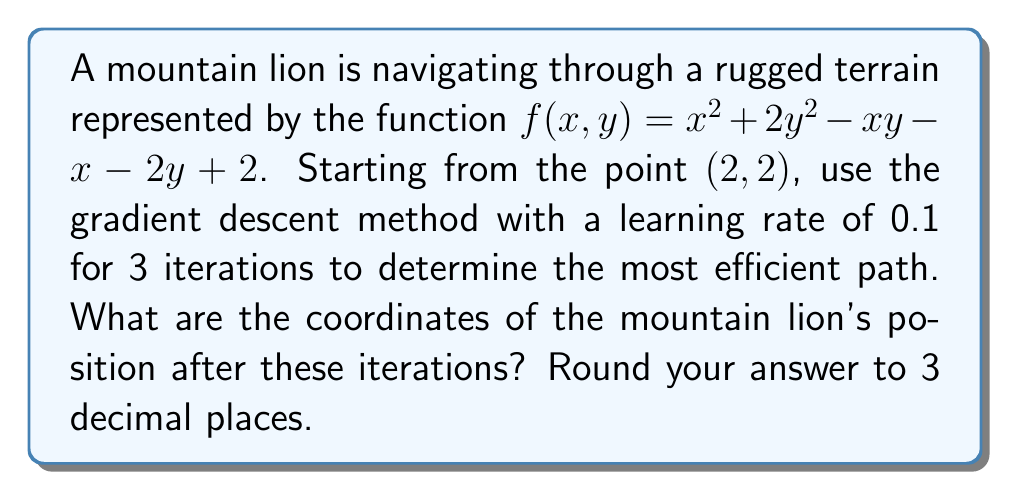Can you solve this math problem? To solve this problem using gradient descent, we follow these steps:

1) Calculate the gradient of $f(x,y)$:
   $$\nabla f(x,y) = \begin{bmatrix} 
   \frac{\partial f}{\partial x} \\
   \frac{\partial f}{\partial y}
   \end{bmatrix} = \begin{bmatrix}
   2x - y - 1 \\
   4y - x - 2
   \end{bmatrix}$$

2) Start at the initial point $(x_0, y_0) = (2,2)$

3) For each iteration $i$ (where $i = 1,2,3$):
   Calculate new position $(x_i, y_i)$ using the formula:
   $$(x_i, y_i) = (x_{i-1}, y_{i-1}) - 0.1 \cdot \nabla f(x_{i-1}, y_{i-1})$$

   Iteration 1:
   $\nabla f(2,2) = \begin{bmatrix} 2(2) - 2 - 1 \\ 4(2) - 2 - 2 \end{bmatrix} = \begin{bmatrix} 1 \\ 4 \end{bmatrix}$
   $(x_1, y_1) = (2,2) - 0.1 \cdot \begin{bmatrix} 1 \\ 4 \end{bmatrix} = (1.9, 1.6)$

   Iteration 2:
   $\nabla f(1.9, 1.6) = \begin{bmatrix} 2(1.9) - 1.6 - 1 \\ 4(1.6) - 1.9 - 2 \end{bmatrix} = \begin{bmatrix} 1.2 \\ 2.5 \end{bmatrix}$
   $(x_2, y_2) = (1.9, 1.6) - 0.1 \cdot \begin{bmatrix} 1.2 \\ 2.5 \end{bmatrix} = (1.78, 1.35)$

   Iteration 3:
   $\nabla f(1.78, 1.35) = \begin{bmatrix} 2(1.78) - 1.35 - 1 \\ 4(1.35) - 1.78 - 2 \end{bmatrix} = \begin{bmatrix} 1.21 \\ 1.62 \end{bmatrix}$
   $(x_3, y_3) = (1.78, 1.35) - 0.1 \cdot \begin{bmatrix} 1.21 \\ 1.62 \end{bmatrix} = (1.659, 1.188)$

4) Round the final coordinates to 3 decimal places: (1.659, 1.188)
Answer: (1.659, 1.188) 